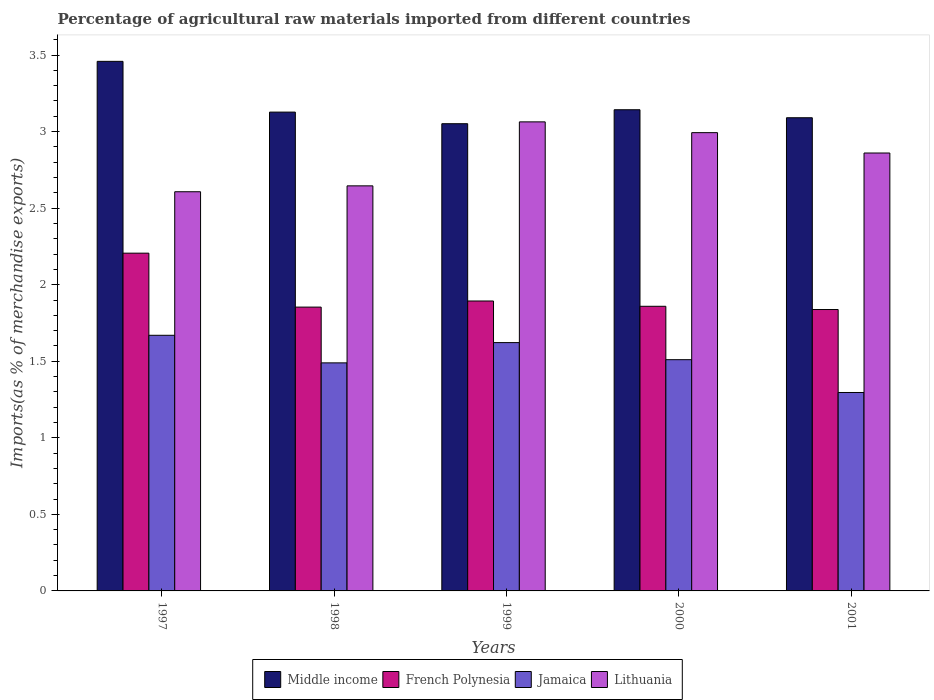How many groups of bars are there?
Give a very brief answer. 5. Are the number of bars per tick equal to the number of legend labels?
Your answer should be very brief. Yes. What is the label of the 3rd group of bars from the left?
Offer a terse response. 1999. What is the percentage of imports to different countries in Lithuania in 2001?
Offer a terse response. 2.86. Across all years, what is the maximum percentage of imports to different countries in Jamaica?
Your answer should be very brief. 1.67. Across all years, what is the minimum percentage of imports to different countries in Jamaica?
Provide a short and direct response. 1.3. In which year was the percentage of imports to different countries in French Polynesia minimum?
Provide a short and direct response. 2001. What is the total percentage of imports to different countries in Lithuania in the graph?
Offer a terse response. 14.17. What is the difference between the percentage of imports to different countries in French Polynesia in 1997 and that in 2000?
Offer a very short reply. 0.35. What is the difference between the percentage of imports to different countries in Lithuania in 1998 and the percentage of imports to different countries in Middle income in 2001?
Your answer should be very brief. -0.44. What is the average percentage of imports to different countries in Lithuania per year?
Your response must be concise. 2.83. In the year 2000, what is the difference between the percentage of imports to different countries in Lithuania and percentage of imports to different countries in Middle income?
Your answer should be very brief. -0.15. What is the ratio of the percentage of imports to different countries in Jamaica in 1998 to that in 1999?
Your answer should be compact. 0.92. What is the difference between the highest and the second highest percentage of imports to different countries in Jamaica?
Provide a short and direct response. 0.05. What is the difference between the highest and the lowest percentage of imports to different countries in Lithuania?
Give a very brief answer. 0.46. What does the 3rd bar from the right in 1998 represents?
Keep it short and to the point. French Polynesia. How many bars are there?
Offer a terse response. 20. How many years are there in the graph?
Ensure brevity in your answer.  5. What is the difference between two consecutive major ticks on the Y-axis?
Give a very brief answer. 0.5. Does the graph contain grids?
Your answer should be very brief. No. Where does the legend appear in the graph?
Give a very brief answer. Bottom center. How are the legend labels stacked?
Your answer should be very brief. Horizontal. What is the title of the graph?
Your response must be concise. Percentage of agricultural raw materials imported from different countries. Does "Lebanon" appear as one of the legend labels in the graph?
Your answer should be compact. No. What is the label or title of the X-axis?
Provide a succinct answer. Years. What is the label or title of the Y-axis?
Offer a terse response. Imports(as % of merchandise exports). What is the Imports(as % of merchandise exports) in Middle income in 1997?
Your answer should be very brief. 3.46. What is the Imports(as % of merchandise exports) in French Polynesia in 1997?
Provide a succinct answer. 2.21. What is the Imports(as % of merchandise exports) in Jamaica in 1997?
Offer a terse response. 1.67. What is the Imports(as % of merchandise exports) in Lithuania in 1997?
Offer a terse response. 2.61. What is the Imports(as % of merchandise exports) of Middle income in 1998?
Give a very brief answer. 3.13. What is the Imports(as % of merchandise exports) in French Polynesia in 1998?
Offer a very short reply. 1.85. What is the Imports(as % of merchandise exports) of Jamaica in 1998?
Make the answer very short. 1.49. What is the Imports(as % of merchandise exports) in Lithuania in 1998?
Give a very brief answer. 2.65. What is the Imports(as % of merchandise exports) of Middle income in 1999?
Keep it short and to the point. 3.05. What is the Imports(as % of merchandise exports) of French Polynesia in 1999?
Your answer should be compact. 1.89. What is the Imports(as % of merchandise exports) of Jamaica in 1999?
Offer a terse response. 1.62. What is the Imports(as % of merchandise exports) of Lithuania in 1999?
Your answer should be compact. 3.06. What is the Imports(as % of merchandise exports) of Middle income in 2000?
Provide a short and direct response. 3.14. What is the Imports(as % of merchandise exports) of French Polynesia in 2000?
Provide a succinct answer. 1.86. What is the Imports(as % of merchandise exports) of Jamaica in 2000?
Keep it short and to the point. 1.51. What is the Imports(as % of merchandise exports) of Lithuania in 2000?
Keep it short and to the point. 2.99. What is the Imports(as % of merchandise exports) in Middle income in 2001?
Offer a terse response. 3.09. What is the Imports(as % of merchandise exports) of French Polynesia in 2001?
Make the answer very short. 1.84. What is the Imports(as % of merchandise exports) in Jamaica in 2001?
Keep it short and to the point. 1.3. What is the Imports(as % of merchandise exports) in Lithuania in 2001?
Make the answer very short. 2.86. Across all years, what is the maximum Imports(as % of merchandise exports) of Middle income?
Provide a succinct answer. 3.46. Across all years, what is the maximum Imports(as % of merchandise exports) in French Polynesia?
Your response must be concise. 2.21. Across all years, what is the maximum Imports(as % of merchandise exports) in Jamaica?
Keep it short and to the point. 1.67. Across all years, what is the maximum Imports(as % of merchandise exports) of Lithuania?
Keep it short and to the point. 3.06. Across all years, what is the minimum Imports(as % of merchandise exports) of Middle income?
Your answer should be very brief. 3.05. Across all years, what is the minimum Imports(as % of merchandise exports) in French Polynesia?
Ensure brevity in your answer.  1.84. Across all years, what is the minimum Imports(as % of merchandise exports) of Jamaica?
Offer a very short reply. 1.3. Across all years, what is the minimum Imports(as % of merchandise exports) in Lithuania?
Make the answer very short. 2.61. What is the total Imports(as % of merchandise exports) in Middle income in the graph?
Provide a succinct answer. 15.87. What is the total Imports(as % of merchandise exports) of French Polynesia in the graph?
Offer a very short reply. 9.65. What is the total Imports(as % of merchandise exports) of Jamaica in the graph?
Provide a short and direct response. 7.59. What is the total Imports(as % of merchandise exports) of Lithuania in the graph?
Make the answer very short. 14.17. What is the difference between the Imports(as % of merchandise exports) of Middle income in 1997 and that in 1998?
Give a very brief answer. 0.33. What is the difference between the Imports(as % of merchandise exports) of French Polynesia in 1997 and that in 1998?
Make the answer very short. 0.35. What is the difference between the Imports(as % of merchandise exports) of Jamaica in 1997 and that in 1998?
Your answer should be compact. 0.18. What is the difference between the Imports(as % of merchandise exports) of Lithuania in 1997 and that in 1998?
Your answer should be very brief. -0.04. What is the difference between the Imports(as % of merchandise exports) of Middle income in 1997 and that in 1999?
Your answer should be very brief. 0.41. What is the difference between the Imports(as % of merchandise exports) of French Polynesia in 1997 and that in 1999?
Give a very brief answer. 0.31. What is the difference between the Imports(as % of merchandise exports) of Jamaica in 1997 and that in 1999?
Your answer should be compact. 0.05. What is the difference between the Imports(as % of merchandise exports) of Lithuania in 1997 and that in 1999?
Keep it short and to the point. -0.46. What is the difference between the Imports(as % of merchandise exports) of Middle income in 1997 and that in 2000?
Give a very brief answer. 0.32. What is the difference between the Imports(as % of merchandise exports) of French Polynesia in 1997 and that in 2000?
Give a very brief answer. 0.35. What is the difference between the Imports(as % of merchandise exports) in Jamaica in 1997 and that in 2000?
Offer a very short reply. 0.16. What is the difference between the Imports(as % of merchandise exports) of Lithuania in 1997 and that in 2000?
Provide a short and direct response. -0.39. What is the difference between the Imports(as % of merchandise exports) of Middle income in 1997 and that in 2001?
Provide a short and direct response. 0.37. What is the difference between the Imports(as % of merchandise exports) of French Polynesia in 1997 and that in 2001?
Your answer should be very brief. 0.37. What is the difference between the Imports(as % of merchandise exports) of Jamaica in 1997 and that in 2001?
Your answer should be very brief. 0.37. What is the difference between the Imports(as % of merchandise exports) in Lithuania in 1997 and that in 2001?
Keep it short and to the point. -0.25. What is the difference between the Imports(as % of merchandise exports) of Middle income in 1998 and that in 1999?
Ensure brevity in your answer.  0.08. What is the difference between the Imports(as % of merchandise exports) in French Polynesia in 1998 and that in 1999?
Your response must be concise. -0.04. What is the difference between the Imports(as % of merchandise exports) in Jamaica in 1998 and that in 1999?
Make the answer very short. -0.13. What is the difference between the Imports(as % of merchandise exports) in Lithuania in 1998 and that in 1999?
Give a very brief answer. -0.42. What is the difference between the Imports(as % of merchandise exports) in Middle income in 1998 and that in 2000?
Your response must be concise. -0.02. What is the difference between the Imports(as % of merchandise exports) in French Polynesia in 1998 and that in 2000?
Offer a very short reply. -0.01. What is the difference between the Imports(as % of merchandise exports) in Jamaica in 1998 and that in 2000?
Give a very brief answer. -0.02. What is the difference between the Imports(as % of merchandise exports) of Lithuania in 1998 and that in 2000?
Provide a short and direct response. -0.35. What is the difference between the Imports(as % of merchandise exports) of Middle income in 1998 and that in 2001?
Your answer should be very brief. 0.04. What is the difference between the Imports(as % of merchandise exports) of French Polynesia in 1998 and that in 2001?
Offer a very short reply. 0.02. What is the difference between the Imports(as % of merchandise exports) of Jamaica in 1998 and that in 2001?
Your answer should be compact. 0.19. What is the difference between the Imports(as % of merchandise exports) in Lithuania in 1998 and that in 2001?
Give a very brief answer. -0.21. What is the difference between the Imports(as % of merchandise exports) in Middle income in 1999 and that in 2000?
Your response must be concise. -0.09. What is the difference between the Imports(as % of merchandise exports) in French Polynesia in 1999 and that in 2000?
Provide a short and direct response. 0.03. What is the difference between the Imports(as % of merchandise exports) of Jamaica in 1999 and that in 2000?
Make the answer very short. 0.11. What is the difference between the Imports(as % of merchandise exports) in Lithuania in 1999 and that in 2000?
Give a very brief answer. 0.07. What is the difference between the Imports(as % of merchandise exports) in Middle income in 1999 and that in 2001?
Provide a succinct answer. -0.04. What is the difference between the Imports(as % of merchandise exports) in French Polynesia in 1999 and that in 2001?
Your response must be concise. 0.06. What is the difference between the Imports(as % of merchandise exports) of Jamaica in 1999 and that in 2001?
Give a very brief answer. 0.33. What is the difference between the Imports(as % of merchandise exports) in Lithuania in 1999 and that in 2001?
Your answer should be compact. 0.2. What is the difference between the Imports(as % of merchandise exports) in Middle income in 2000 and that in 2001?
Offer a very short reply. 0.05. What is the difference between the Imports(as % of merchandise exports) in French Polynesia in 2000 and that in 2001?
Give a very brief answer. 0.02. What is the difference between the Imports(as % of merchandise exports) of Jamaica in 2000 and that in 2001?
Keep it short and to the point. 0.21. What is the difference between the Imports(as % of merchandise exports) of Lithuania in 2000 and that in 2001?
Ensure brevity in your answer.  0.13. What is the difference between the Imports(as % of merchandise exports) in Middle income in 1997 and the Imports(as % of merchandise exports) in French Polynesia in 1998?
Keep it short and to the point. 1.6. What is the difference between the Imports(as % of merchandise exports) of Middle income in 1997 and the Imports(as % of merchandise exports) of Jamaica in 1998?
Ensure brevity in your answer.  1.97. What is the difference between the Imports(as % of merchandise exports) of Middle income in 1997 and the Imports(as % of merchandise exports) of Lithuania in 1998?
Provide a succinct answer. 0.81. What is the difference between the Imports(as % of merchandise exports) of French Polynesia in 1997 and the Imports(as % of merchandise exports) of Jamaica in 1998?
Offer a terse response. 0.72. What is the difference between the Imports(as % of merchandise exports) of French Polynesia in 1997 and the Imports(as % of merchandise exports) of Lithuania in 1998?
Make the answer very short. -0.44. What is the difference between the Imports(as % of merchandise exports) in Jamaica in 1997 and the Imports(as % of merchandise exports) in Lithuania in 1998?
Offer a very short reply. -0.98. What is the difference between the Imports(as % of merchandise exports) of Middle income in 1997 and the Imports(as % of merchandise exports) of French Polynesia in 1999?
Provide a succinct answer. 1.57. What is the difference between the Imports(as % of merchandise exports) of Middle income in 1997 and the Imports(as % of merchandise exports) of Jamaica in 1999?
Make the answer very short. 1.84. What is the difference between the Imports(as % of merchandise exports) of Middle income in 1997 and the Imports(as % of merchandise exports) of Lithuania in 1999?
Provide a short and direct response. 0.4. What is the difference between the Imports(as % of merchandise exports) in French Polynesia in 1997 and the Imports(as % of merchandise exports) in Jamaica in 1999?
Offer a terse response. 0.58. What is the difference between the Imports(as % of merchandise exports) of French Polynesia in 1997 and the Imports(as % of merchandise exports) of Lithuania in 1999?
Keep it short and to the point. -0.86. What is the difference between the Imports(as % of merchandise exports) of Jamaica in 1997 and the Imports(as % of merchandise exports) of Lithuania in 1999?
Your answer should be compact. -1.39. What is the difference between the Imports(as % of merchandise exports) in Middle income in 1997 and the Imports(as % of merchandise exports) in French Polynesia in 2000?
Your response must be concise. 1.6. What is the difference between the Imports(as % of merchandise exports) of Middle income in 1997 and the Imports(as % of merchandise exports) of Jamaica in 2000?
Offer a very short reply. 1.95. What is the difference between the Imports(as % of merchandise exports) of Middle income in 1997 and the Imports(as % of merchandise exports) of Lithuania in 2000?
Keep it short and to the point. 0.47. What is the difference between the Imports(as % of merchandise exports) in French Polynesia in 1997 and the Imports(as % of merchandise exports) in Jamaica in 2000?
Give a very brief answer. 0.7. What is the difference between the Imports(as % of merchandise exports) in French Polynesia in 1997 and the Imports(as % of merchandise exports) in Lithuania in 2000?
Provide a short and direct response. -0.79. What is the difference between the Imports(as % of merchandise exports) in Jamaica in 1997 and the Imports(as % of merchandise exports) in Lithuania in 2000?
Give a very brief answer. -1.32. What is the difference between the Imports(as % of merchandise exports) of Middle income in 1997 and the Imports(as % of merchandise exports) of French Polynesia in 2001?
Offer a very short reply. 1.62. What is the difference between the Imports(as % of merchandise exports) of Middle income in 1997 and the Imports(as % of merchandise exports) of Jamaica in 2001?
Keep it short and to the point. 2.16. What is the difference between the Imports(as % of merchandise exports) in Middle income in 1997 and the Imports(as % of merchandise exports) in Lithuania in 2001?
Your answer should be very brief. 0.6. What is the difference between the Imports(as % of merchandise exports) in French Polynesia in 1997 and the Imports(as % of merchandise exports) in Jamaica in 2001?
Offer a terse response. 0.91. What is the difference between the Imports(as % of merchandise exports) in French Polynesia in 1997 and the Imports(as % of merchandise exports) in Lithuania in 2001?
Provide a succinct answer. -0.65. What is the difference between the Imports(as % of merchandise exports) of Jamaica in 1997 and the Imports(as % of merchandise exports) of Lithuania in 2001?
Give a very brief answer. -1.19. What is the difference between the Imports(as % of merchandise exports) of Middle income in 1998 and the Imports(as % of merchandise exports) of French Polynesia in 1999?
Your answer should be very brief. 1.23. What is the difference between the Imports(as % of merchandise exports) in Middle income in 1998 and the Imports(as % of merchandise exports) in Jamaica in 1999?
Your response must be concise. 1.51. What is the difference between the Imports(as % of merchandise exports) of Middle income in 1998 and the Imports(as % of merchandise exports) of Lithuania in 1999?
Offer a terse response. 0.06. What is the difference between the Imports(as % of merchandise exports) of French Polynesia in 1998 and the Imports(as % of merchandise exports) of Jamaica in 1999?
Provide a short and direct response. 0.23. What is the difference between the Imports(as % of merchandise exports) of French Polynesia in 1998 and the Imports(as % of merchandise exports) of Lithuania in 1999?
Your answer should be very brief. -1.21. What is the difference between the Imports(as % of merchandise exports) of Jamaica in 1998 and the Imports(as % of merchandise exports) of Lithuania in 1999?
Provide a short and direct response. -1.57. What is the difference between the Imports(as % of merchandise exports) of Middle income in 1998 and the Imports(as % of merchandise exports) of French Polynesia in 2000?
Your response must be concise. 1.27. What is the difference between the Imports(as % of merchandise exports) in Middle income in 1998 and the Imports(as % of merchandise exports) in Jamaica in 2000?
Your answer should be very brief. 1.62. What is the difference between the Imports(as % of merchandise exports) in Middle income in 1998 and the Imports(as % of merchandise exports) in Lithuania in 2000?
Your answer should be compact. 0.13. What is the difference between the Imports(as % of merchandise exports) of French Polynesia in 1998 and the Imports(as % of merchandise exports) of Jamaica in 2000?
Give a very brief answer. 0.34. What is the difference between the Imports(as % of merchandise exports) of French Polynesia in 1998 and the Imports(as % of merchandise exports) of Lithuania in 2000?
Ensure brevity in your answer.  -1.14. What is the difference between the Imports(as % of merchandise exports) of Jamaica in 1998 and the Imports(as % of merchandise exports) of Lithuania in 2000?
Provide a short and direct response. -1.5. What is the difference between the Imports(as % of merchandise exports) in Middle income in 1998 and the Imports(as % of merchandise exports) in French Polynesia in 2001?
Offer a terse response. 1.29. What is the difference between the Imports(as % of merchandise exports) in Middle income in 1998 and the Imports(as % of merchandise exports) in Jamaica in 2001?
Your answer should be very brief. 1.83. What is the difference between the Imports(as % of merchandise exports) in Middle income in 1998 and the Imports(as % of merchandise exports) in Lithuania in 2001?
Make the answer very short. 0.27. What is the difference between the Imports(as % of merchandise exports) in French Polynesia in 1998 and the Imports(as % of merchandise exports) in Jamaica in 2001?
Give a very brief answer. 0.56. What is the difference between the Imports(as % of merchandise exports) in French Polynesia in 1998 and the Imports(as % of merchandise exports) in Lithuania in 2001?
Provide a succinct answer. -1.01. What is the difference between the Imports(as % of merchandise exports) in Jamaica in 1998 and the Imports(as % of merchandise exports) in Lithuania in 2001?
Your answer should be very brief. -1.37. What is the difference between the Imports(as % of merchandise exports) in Middle income in 1999 and the Imports(as % of merchandise exports) in French Polynesia in 2000?
Your answer should be compact. 1.19. What is the difference between the Imports(as % of merchandise exports) of Middle income in 1999 and the Imports(as % of merchandise exports) of Jamaica in 2000?
Make the answer very short. 1.54. What is the difference between the Imports(as % of merchandise exports) in Middle income in 1999 and the Imports(as % of merchandise exports) in Lithuania in 2000?
Ensure brevity in your answer.  0.06. What is the difference between the Imports(as % of merchandise exports) in French Polynesia in 1999 and the Imports(as % of merchandise exports) in Jamaica in 2000?
Make the answer very short. 0.38. What is the difference between the Imports(as % of merchandise exports) of French Polynesia in 1999 and the Imports(as % of merchandise exports) of Lithuania in 2000?
Give a very brief answer. -1.1. What is the difference between the Imports(as % of merchandise exports) in Jamaica in 1999 and the Imports(as % of merchandise exports) in Lithuania in 2000?
Your response must be concise. -1.37. What is the difference between the Imports(as % of merchandise exports) in Middle income in 1999 and the Imports(as % of merchandise exports) in French Polynesia in 2001?
Keep it short and to the point. 1.21. What is the difference between the Imports(as % of merchandise exports) in Middle income in 1999 and the Imports(as % of merchandise exports) in Jamaica in 2001?
Give a very brief answer. 1.76. What is the difference between the Imports(as % of merchandise exports) in Middle income in 1999 and the Imports(as % of merchandise exports) in Lithuania in 2001?
Your answer should be very brief. 0.19. What is the difference between the Imports(as % of merchandise exports) of French Polynesia in 1999 and the Imports(as % of merchandise exports) of Jamaica in 2001?
Offer a terse response. 0.6. What is the difference between the Imports(as % of merchandise exports) in French Polynesia in 1999 and the Imports(as % of merchandise exports) in Lithuania in 2001?
Your answer should be compact. -0.97. What is the difference between the Imports(as % of merchandise exports) in Jamaica in 1999 and the Imports(as % of merchandise exports) in Lithuania in 2001?
Your response must be concise. -1.24. What is the difference between the Imports(as % of merchandise exports) of Middle income in 2000 and the Imports(as % of merchandise exports) of French Polynesia in 2001?
Your response must be concise. 1.3. What is the difference between the Imports(as % of merchandise exports) in Middle income in 2000 and the Imports(as % of merchandise exports) in Jamaica in 2001?
Offer a terse response. 1.85. What is the difference between the Imports(as % of merchandise exports) in Middle income in 2000 and the Imports(as % of merchandise exports) in Lithuania in 2001?
Your response must be concise. 0.28. What is the difference between the Imports(as % of merchandise exports) in French Polynesia in 2000 and the Imports(as % of merchandise exports) in Jamaica in 2001?
Your answer should be compact. 0.56. What is the difference between the Imports(as % of merchandise exports) of French Polynesia in 2000 and the Imports(as % of merchandise exports) of Lithuania in 2001?
Your answer should be very brief. -1. What is the difference between the Imports(as % of merchandise exports) in Jamaica in 2000 and the Imports(as % of merchandise exports) in Lithuania in 2001?
Your answer should be compact. -1.35. What is the average Imports(as % of merchandise exports) in Middle income per year?
Provide a short and direct response. 3.17. What is the average Imports(as % of merchandise exports) in French Polynesia per year?
Offer a terse response. 1.93. What is the average Imports(as % of merchandise exports) in Jamaica per year?
Your answer should be very brief. 1.52. What is the average Imports(as % of merchandise exports) of Lithuania per year?
Your response must be concise. 2.83. In the year 1997, what is the difference between the Imports(as % of merchandise exports) in Middle income and Imports(as % of merchandise exports) in French Polynesia?
Provide a short and direct response. 1.25. In the year 1997, what is the difference between the Imports(as % of merchandise exports) of Middle income and Imports(as % of merchandise exports) of Jamaica?
Keep it short and to the point. 1.79. In the year 1997, what is the difference between the Imports(as % of merchandise exports) of Middle income and Imports(as % of merchandise exports) of Lithuania?
Make the answer very short. 0.85. In the year 1997, what is the difference between the Imports(as % of merchandise exports) in French Polynesia and Imports(as % of merchandise exports) in Jamaica?
Your answer should be very brief. 0.54. In the year 1997, what is the difference between the Imports(as % of merchandise exports) of French Polynesia and Imports(as % of merchandise exports) of Lithuania?
Give a very brief answer. -0.4. In the year 1997, what is the difference between the Imports(as % of merchandise exports) of Jamaica and Imports(as % of merchandise exports) of Lithuania?
Your answer should be compact. -0.94. In the year 1998, what is the difference between the Imports(as % of merchandise exports) in Middle income and Imports(as % of merchandise exports) in French Polynesia?
Offer a very short reply. 1.27. In the year 1998, what is the difference between the Imports(as % of merchandise exports) in Middle income and Imports(as % of merchandise exports) in Jamaica?
Your answer should be very brief. 1.64. In the year 1998, what is the difference between the Imports(as % of merchandise exports) in Middle income and Imports(as % of merchandise exports) in Lithuania?
Offer a terse response. 0.48. In the year 1998, what is the difference between the Imports(as % of merchandise exports) of French Polynesia and Imports(as % of merchandise exports) of Jamaica?
Ensure brevity in your answer.  0.36. In the year 1998, what is the difference between the Imports(as % of merchandise exports) of French Polynesia and Imports(as % of merchandise exports) of Lithuania?
Keep it short and to the point. -0.79. In the year 1998, what is the difference between the Imports(as % of merchandise exports) in Jamaica and Imports(as % of merchandise exports) in Lithuania?
Your answer should be very brief. -1.16. In the year 1999, what is the difference between the Imports(as % of merchandise exports) of Middle income and Imports(as % of merchandise exports) of French Polynesia?
Provide a short and direct response. 1.16. In the year 1999, what is the difference between the Imports(as % of merchandise exports) of Middle income and Imports(as % of merchandise exports) of Jamaica?
Make the answer very short. 1.43. In the year 1999, what is the difference between the Imports(as % of merchandise exports) in Middle income and Imports(as % of merchandise exports) in Lithuania?
Keep it short and to the point. -0.01. In the year 1999, what is the difference between the Imports(as % of merchandise exports) of French Polynesia and Imports(as % of merchandise exports) of Jamaica?
Your response must be concise. 0.27. In the year 1999, what is the difference between the Imports(as % of merchandise exports) of French Polynesia and Imports(as % of merchandise exports) of Lithuania?
Keep it short and to the point. -1.17. In the year 1999, what is the difference between the Imports(as % of merchandise exports) of Jamaica and Imports(as % of merchandise exports) of Lithuania?
Offer a terse response. -1.44. In the year 2000, what is the difference between the Imports(as % of merchandise exports) of Middle income and Imports(as % of merchandise exports) of French Polynesia?
Your answer should be very brief. 1.28. In the year 2000, what is the difference between the Imports(as % of merchandise exports) in Middle income and Imports(as % of merchandise exports) in Jamaica?
Offer a terse response. 1.63. In the year 2000, what is the difference between the Imports(as % of merchandise exports) in Middle income and Imports(as % of merchandise exports) in Lithuania?
Provide a succinct answer. 0.15. In the year 2000, what is the difference between the Imports(as % of merchandise exports) of French Polynesia and Imports(as % of merchandise exports) of Jamaica?
Your answer should be compact. 0.35. In the year 2000, what is the difference between the Imports(as % of merchandise exports) of French Polynesia and Imports(as % of merchandise exports) of Lithuania?
Your answer should be very brief. -1.13. In the year 2000, what is the difference between the Imports(as % of merchandise exports) in Jamaica and Imports(as % of merchandise exports) in Lithuania?
Provide a succinct answer. -1.48. In the year 2001, what is the difference between the Imports(as % of merchandise exports) in Middle income and Imports(as % of merchandise exports) in French Polynesia?
Offer a terse response. 1.25. In the year 2001, what is the difference between the Imports(as % of merchandise exports) of Middle income and Imports(as % of merchandise exports) of Jamaica?
Your response must be concise. 1.79. In the year 2001, what is the difference between the Imports(as % of merchandise exports) in Middle income and Imports(as % of merchandise exports) in Lithuania?
Keep it short and to the point. 0.23. In the year 2001, what is the difference between the Imports(as % of merchandise exports) in French Polynesia and Imports(as % of merchandise exports) in Jamaica?
Provide a succinct answer. 0.54. In the year 2001, what is the difference between the Imports(as % of merchandise exports) in French Polynesia and Imports(as % of merchandise exports) in Lithuania?
Your answer should be very brief. -1.02. In the year 2001, what is the difference between the Imports(as % of merchandise exports) in Jamaica and Imports(as % of merchandise exports) in Lithuania?
Offer a very short reply. -1.56. What is the ratio of the Imports(as % of merchandise exports) of Middle income in 1997 to that in 1998?
Your answer should be compact. 1.11. What is the ratio of the Imports(as % of merchandise exports) in French Polynesia in 1997 to that in 1998?
Offer a terse response. 1.19. What is the ratio of the Imports(as % of merchandise exports) in Jamaica in 1997 to that in 1998?
Keep it short and to the point. 1.12. What is the ratio of the Imports(as % of merchandise exports) of Lithuania in 1997 to that in 1998?
Offer a very short reply. 0.99. What is the ratio of the Imports(as % of merchandise exports) of Middle income in 1997 to that in 1999?
Provide a short and direct response. 1.13. What is the ratio of the Imports(as % of merchandise exports) in French Polynesia in 1997 to that in 1999?
Your answer should be compact. 1.17. What is the ratio of the Imports(as % of merchandise exports) in Jamaica in 1997 to that in 1999?
Keep it short and to the point. 1.03. What is the ratio of the Imports(as % of merchandise exports) in Lithuania in 1997 to that in 1999?
Make the answer very short. 0.85. What is the ratio of the Imports(as % of merchandise exports) of Middle income in 1997 to that in 2000?
Your response must be concise. 1.1. What is the ratio of the Imports(as % of merchandise exports) in French Polynesia in 1997 to that in 2000?
Ensure brevity in your answer.  1.19. What is the ratio of the Imports(as % of merchandise exports) of Jamaica in 1997 to that in 2000?
Your response must be concise. 1.11. What is the ratio of the Imports(as % of merchandise exports) in Lithuania in 1997 to that in 2000?
Keep it short and to the point. 0.87. What is the ratio of the Imports(as % of merchandise exports) in Middle income in 1997 to that in 2001?
Offer a very short reply. 1.12. What is the ratio of the Imports(as % of merchandise exports) in French Polynesia in 1997 to that in 2001?
Your answer should be compact. 1.2. What is the ratio of the Imports(as % of merchandise exports) of Jamaica in 1997 to that in 2001?
Keep it short and to the point. 1.29. What is the ratio of the Imports(as % of merchandise exports) of Lithuania in 1997 to that in 2001?
Offer a very short reply. 0.91. What is the ratio of the Imports(as % of merchandise exports) of Middle income in 1998 to that in 1999?
Give a very brief answer. 1.02. What is the ratio of the Imports(as % of merchandise exports) in French Polynesia in 1998 to that in 1999?
Your response must be concise. 0.98. What is the ratio of the Imports(as % of merchandise exports) of Jamaica in 1998 to that in 1999?
Offer a very short reply. 0.92. What is the ratio of the Imports(as % of merchandise exports) in Lithuania in 1998 to that in 1999?
Provide a short and direct response. 0.86. What is the ratio of the Imports(as % of merchandise exports) of Jamaica in 1998 to that in 2000?
Your response must be concise. 0.99. What is the ratio of the Imports(as % of merchandise exports) of Lithuania in 1998 to that in 2000?
Keep it short and to the point. 0.88. What is the ratio of the Imports(as % of merchandise exports) in Middle income in 1998 to that in 2001?
Give a very brief answer. 1.01. What is the ratio of the Imports(as % of merchandise exports) in French Polynesia in 1998 to that in 2001?
Your answer should be compact. 1.01. What is the ratio of the Imports(as % of merchandise exports) of Jamaica in 1998 to that in 2001?
Keep it short and to the point. 1.15. What is the ratio of the Imports(as % of merchandise exports) in Lithuania in 1998 to that in 2001?
Offer a very short reply. 0.93. What is the ratio of the Imports(as % of merchandise exports) of Middle income in 1999 to that in 2000?
Ensure brevity in your answer.  0.97. What is the ratio of the Imports(as % of merchandise exports) in French Polynesia in 1999 to that in 2000?
Your answer should be compact. 1.02. What is the ratio of the Imports(as % of merchandise exports) of Jamaica in 1999 to that in 2000?
Make the answer very short. 1.07. What is the ratio of the Imports(as % of merchandise exports) of Lithuania in 1999 to that in 2000?
Offer a terse response. 1.02. What is the ratio of the Imports(as % of merchandise exports) of Middle income in 1999 to that in 2001?
Provide a succinct answer. 0.99. What is the ratio of the Imports(as % of merchandise exports) of French Polynesia in 1999 to that in 2001?
Provide a succinct answer. 1.03. What is the ratio of the Imports(as % of merchandise exports) of Jamaica in 1999 to that in 2001?
Offer a terse response. 1.25. What is the ratio of the Imports(as % of merchandise exports) in Lithuania in 1999 to that in 2001?
Keep it short and to the point. 1.07. What is the ratio of the Imports(as % of merchandise exports) of Middle income in 2000 to that in 2001?
Keep it short and to the point. 1.02. What is the ratio of the Imports(as % of merchandise exports) of French Polynesia in 2000 to that in 2001?
Offer a very short reply. 1.01. What is the ratio of the Imports(as % of merchandise exports) of Jamaica in 2000 to that in 2001?
Give a very brief answer. 1.17. What is the ratio of the Imports(as % of merchandise exports) of Lithuania in 2000 to that in 2001?
Keep it short and to the point. 1.05. What is the difference between the highest and the second highest Imports(as % of merchandise exports) of Middle income?
Your response must be concise. 0.32. What is the difference between the highest and the second highest Imports(as % of merchandise exports) in French Polynesia?
Provide a succinct answer. 0.31. What is the difference between the highest and the second highest Imports(as % of merchandise exports) in Jamaica?
Your response must be concise. 0.05. What is the difference between the highest and the second highest Imports(as % of merchandise exports) in Lithuania?
Your answer should be compact. 0.07. What is the difference between the highest and the lowest Imports(as % of merchandise exports) in Middle income?
Make the answer very short. 0.41. What is the difference between the highest and the lowest Imports(as % of merchandise exports) in French Polynesia?
Give a very brief answer. 0.37. What is the difference between the highest and the lowest Imports(as % of merchandise exports) of Jamaica?
Your response must be concise. 0.37. What is the difference between the highest and the lowest Imports(as % of merchandise exports) in Lithuania?
Give a very brief answer. 0.46. 